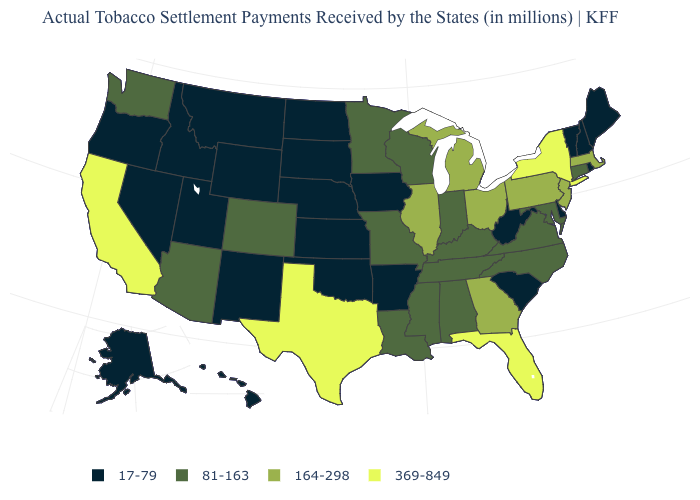Name the states that have a value in the range 81-163?
Write a very short answer. Alabama, Arizona, Colorado, Connecticut, Indiana, Kentucky, Louisiana, Maryland, Minnesota, Mississippi, Missouri, North Carolina, Tennessee, Virginia, Washington, Wisconsin. Name the states that have a value in the range 17-79?
Keep it brief. Alaska, Arkansas, Delaware, Hawaii, Idaho, Iowa, Kansas, Maine, Montana, Nebraska, Nevada, New Hampshire, New Mexico, North Dakota, Oklahoma, Oregon, Rhode Island, South Carolina, South Dakota, Utah, Vermont, West Virginia, Wyoming. Among the states that border Nebraska , which have the lowest value?
Concise answer only. Iowa, Kansas, South Dakota, Wyoming. Name the states that have a value in the range 81-163?
Answer briefly. Alabama, Arizona, Colorado, Connecticut, Indiana, Kentucky, Louisiana, Maryland, Minnesota, Mississippi, Missouri, North Carolina, Tennessee, Virginia, Washington, Wisconsin. Does the map have missing data?
Concise answer only. No. What is the value of Nebraska?
Answer briefly. 17-79. What is the value of Missouri?
Write a very short answer. 81-163. Among the states that border Delaware , which have the lowest value?
Quick response, please. Maryland. What is the value of Michigan?
Answer briefly. 164-298. Name the states that have a value in the range 164-298?
Short answer required. Georgia, Illinois, Massachusetts, Michigan, New Jersey, Ohio, Pennsylvania. Does Kansas have the highest value in the MidWest?
Answer briefly. No. Name the states that have a value in the range 17-79?
Be succinct. Alaska, Arkansas, Delaware, Hawaii, Idaho, Iowa, Kansas, Maine, Montana, Nebraska, Nevada, New Hampshire, New Mexico, North Dakota, Oklahoma, Oregon, Rhode Island, South Carolina, South Dakota, Utah, Vermont, West Virginia, Wyoming. What is the value of Maine?
Short answer required. 17-79. Does California have a lower value than South Dakota?
Quick response, please. No. Which states have the lowest value in the USA?
Short answer required. Alaska, Arkansas, Delaware, Hawaii, Idaho, Iowa, Kansas, Maine, Montana, Nebraska, Nevada, New Hampshire, New Mexico, North Dakota, Oklahoma, Oregon, Rhode Island, South Carolina, South Dakota, Utah, Vermont, West Virginia, Wyoming. 